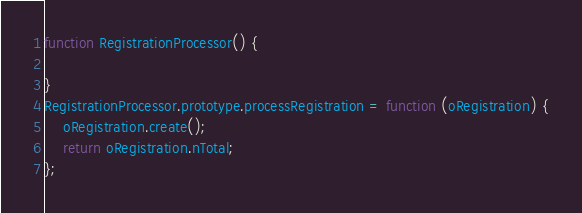Convert code to text. <code><loc_0><loc_0><loc_500><loc_500><_JavaScript_>function RegistrationProcessor() {

}
RegistrationProcessor.prototype.processRegistration = function (oRegistration) {
    oRegistration.create();
    return oRegistration.nTotal;
};</code> 